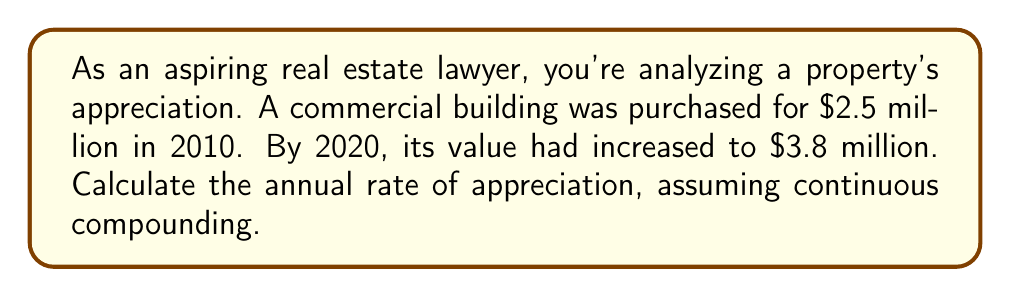Could you help me with this problem? To solve this problem, we'll use the continuous compound interest formula:

$$ A = P \cdot e^{rt} $$

Where:
$A$ = Final amount
$P$ = Principal (initial investment)
$r$ = Annual rate of appreciation
$t$ = Time in years
$e$ = Euler's number (approximately 2.71828)

Given:
$P = \$2.5$ million
$A = \$3.8$ million
$t = 10$ years

Step 1: Substitute the known values into the formula.
$$ 3.8 = 2.5 \cdot e^{10r} $$

Step 2: Divide both sides by 2.5.
$$ \frac{3.8}{2.5} = e^{10r} $$

Step 3: Take the natural logarithm of both sides.
$$ \ln(\frac{3.8}{2.5}) = 10r $$

Step 4: Solve for $r$.
$$ r = \frac{\ln(\frac{3.8}{2.5})}{10} $$

Step 5: Calculate the value of $r$.
$$ r = \frac{\ln(1.52)}{10} \approx 0.0418 $$

Step 6: Convert to a percentage.
$$ 0.0418 \cdot 100\% = 4.18\% $$
Answer: 4.18% 